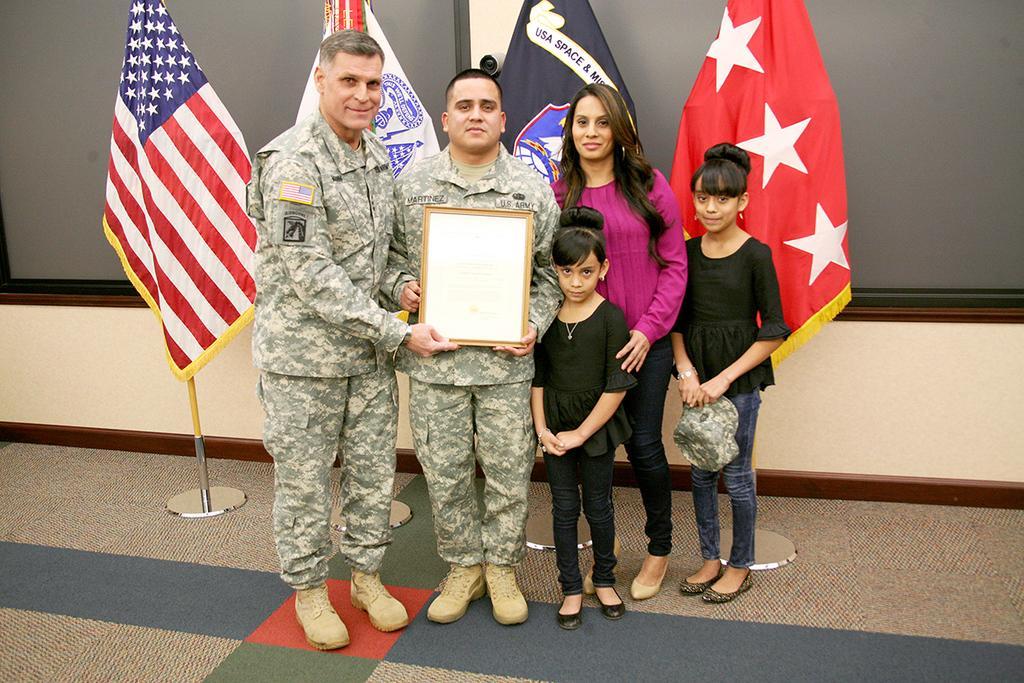Describe this image in one or two sentences. Here in this picture we can see two men in military dresses standing over a place and beside them we can see a woman standing and we can see two children standing over there and he is holding something in his hands and the child is holding a cap in her hand and behind them we can see flag post present on the floor over there and we can see all of them are smiling. 